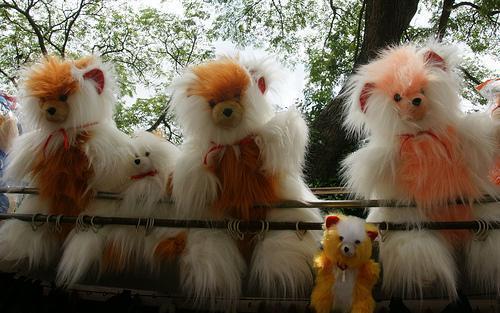How many teddy bears are there?
Give a very brief answer. 5. How many people are wearing a red shirt?
Give a very brief answer. 0. 